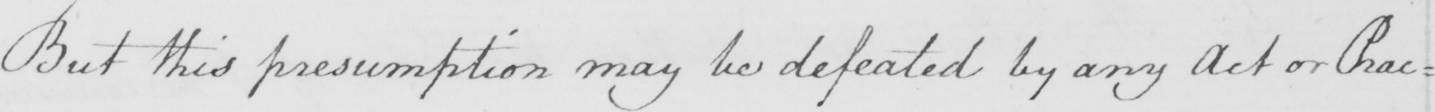Can you tell me what this handwritten text says? But this presumption may be defeated by any Act or Prac : 